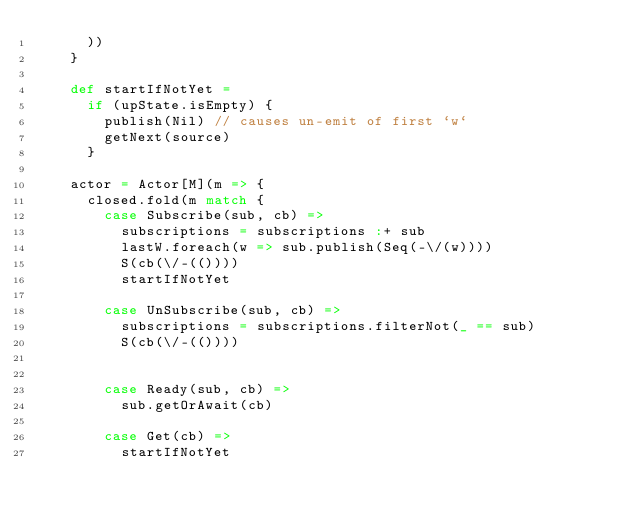<code> <loc_0><loc_0><loc_500><loc_500><_Scala_>      ))
    }

    def startIfNotYet =
      if (upState.isEmpty) {
        publish(Nil) // causes un-emit of first `w`
        getNext(source)
      }

    actor = Actor[M](m => {
      closed.fold(m match {
        case Subscribe(sub, cb) =>
          subscriptions = subscriptions :+ sub
          lastW.foreach(w => sub.publish(Seq(-\/(w))))
          S(cb(\/-(())))
          startIfNotYet

        case UnSubscribe(sub, cb) =>
          subscriptions = subscriptions.filterNot(_ == sub)
          S(cb(\/-(())))


        case Ready(sub, cb) =>
          sub.getOrAwait(cb)

        case Get(cb) =>
          startIfNotYet</code> 